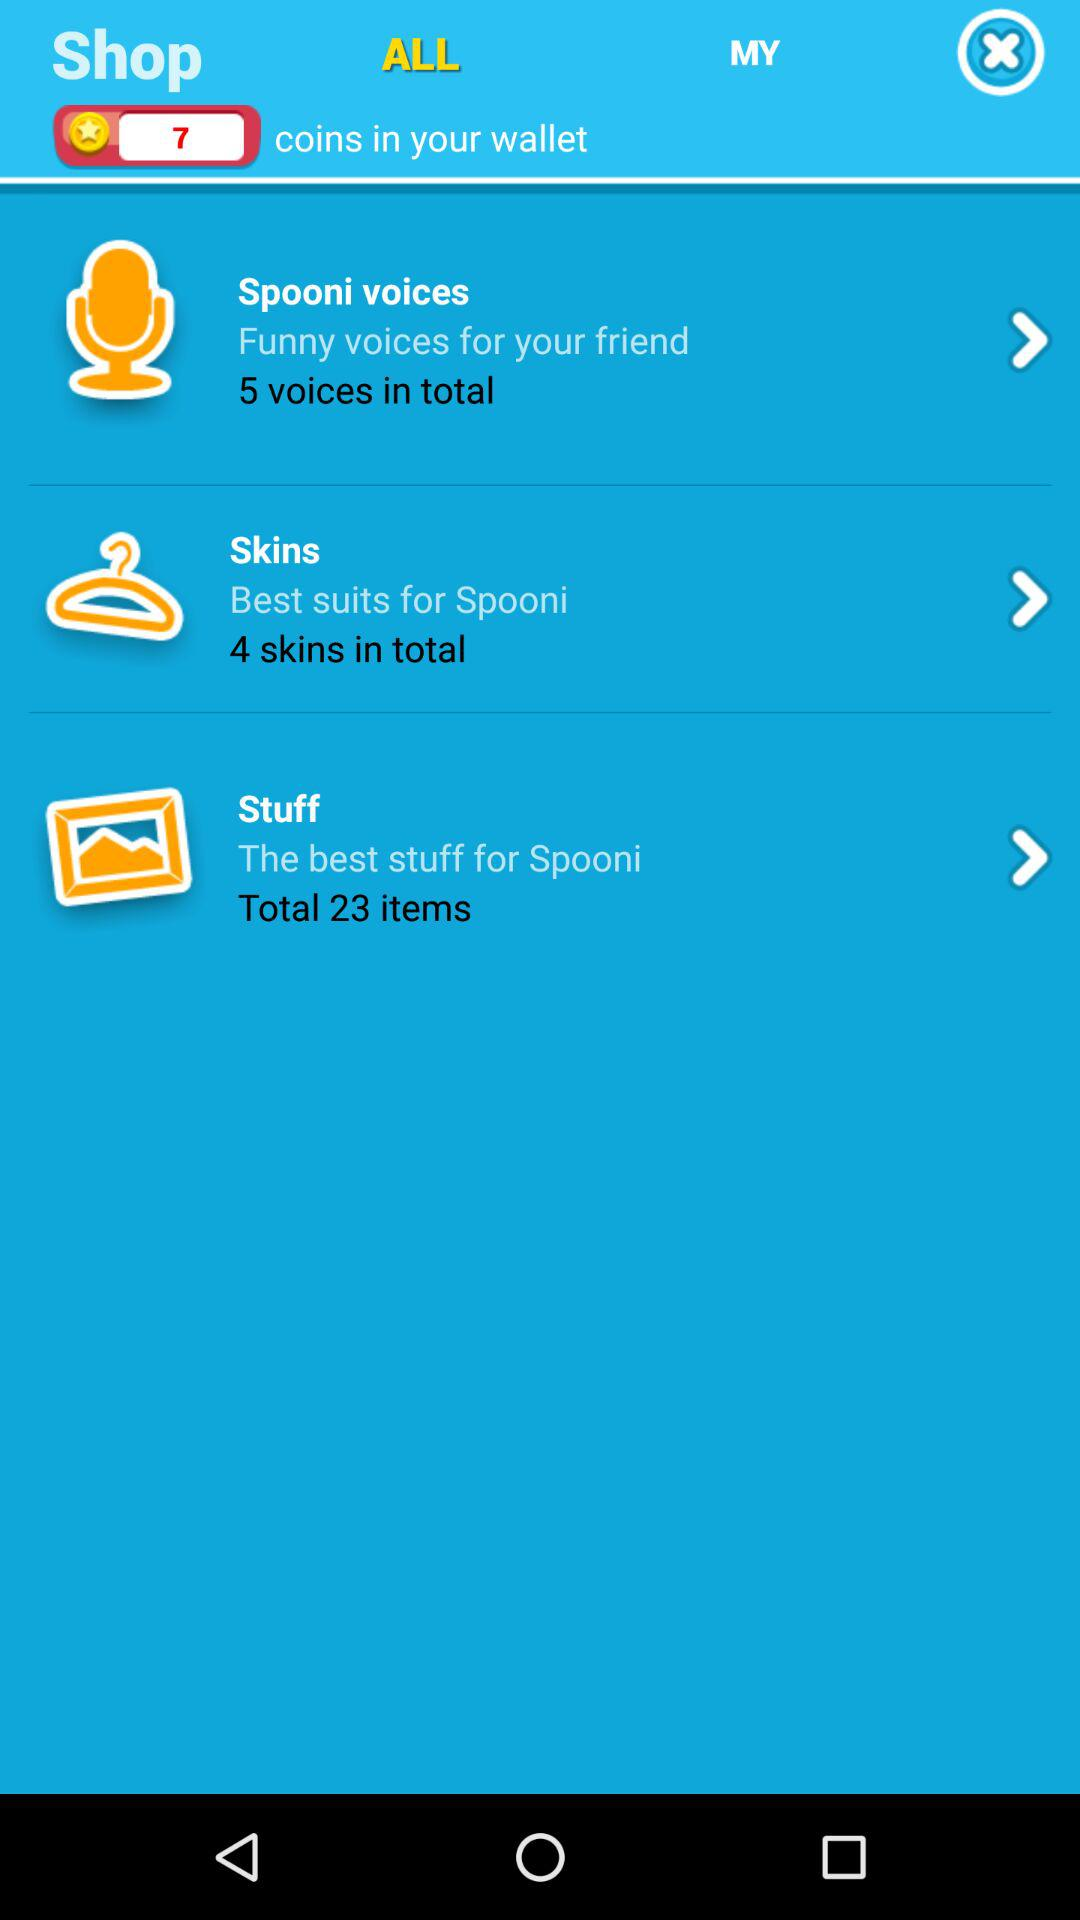How many items in total are included in "Stuff"? There are 23 items included in "Stuff". 